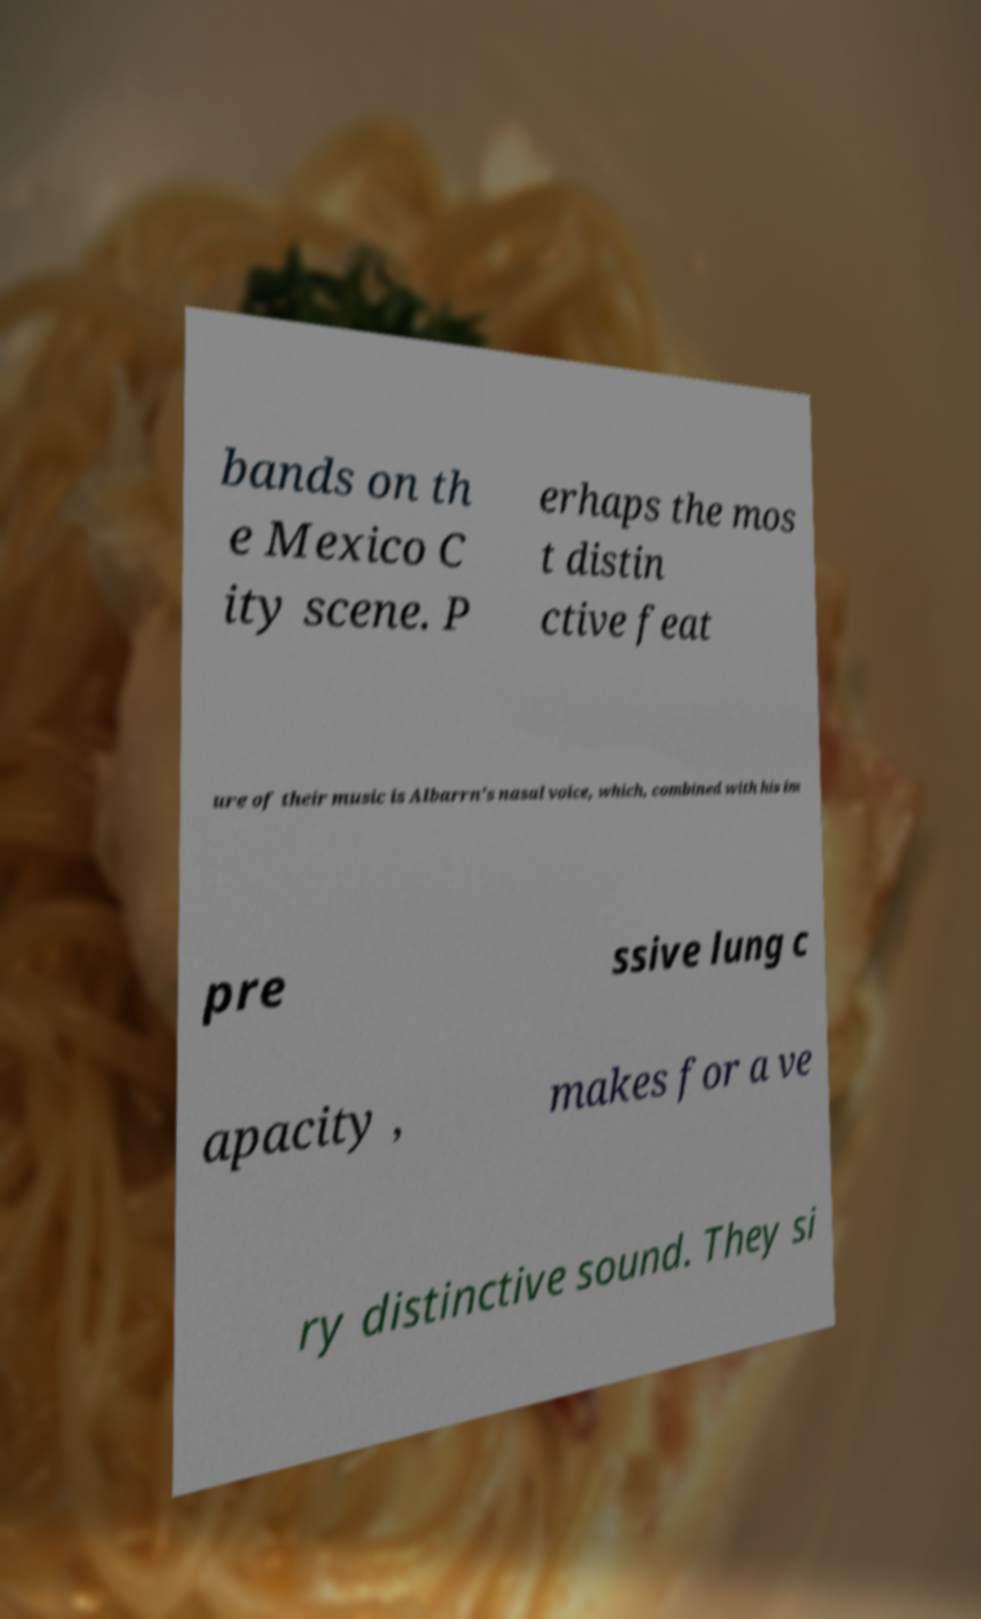Can you accurately transcribe the text from the provided image for me? bands on th e Mexico C ity scene. P erhaps the mos t distin ctive feat ure of their music is Albarrn's nasal voice, which, combined with his im pre ssive lung c apacity , makes for a ve ry distinctive sound. They si 